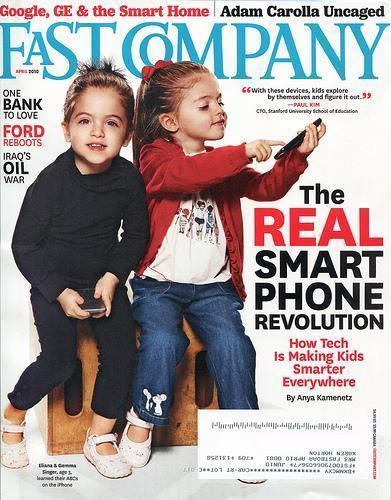How many kids are in the pic?
Give a very brief answer. 2. 